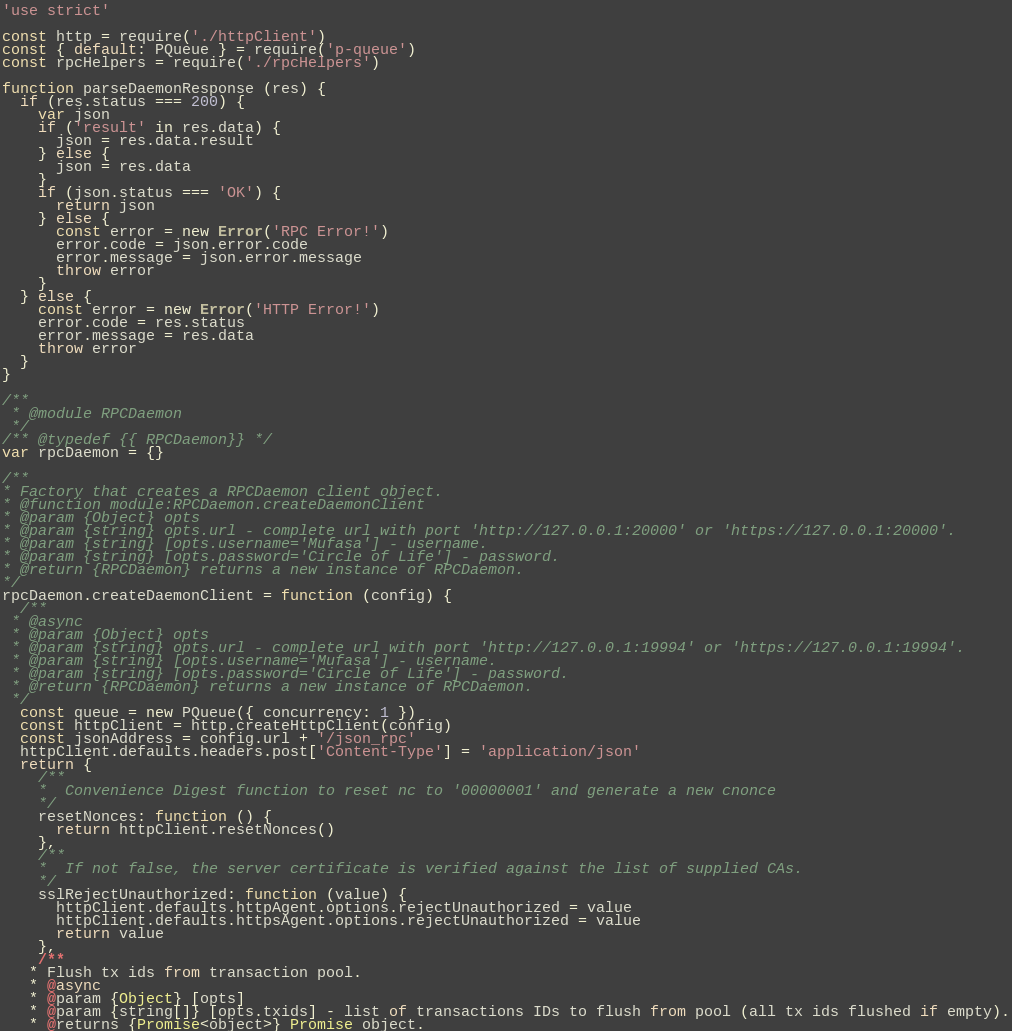<code> <loc_0><loc_0><loc_500><loc_500><_JavaScript_>'use strict'

const http = require('./httpClient')
const { default: PQueue } = require('p-queue')
const rpcHelpers = require('./rpcHelpers')

function parseDaemonResponse (res) {
  if (res.status === 200) {
    var json
    if ('result' in res.data) {
      json = res.data.result
    } else {
      json = res.data
    }
    if (json.status === 'OK') {
      return json
    } else {
      const error = new Error('RPC Error!')
      error.code = json.error.code
      error.message = json.error.message
      throw error
    }
  } else {
    const error = new Error('HTTP Error!')
    error.code = res.status
    error.message = res.data
    throw error
  }
}

/**
 * @module RPCDaemon
 */
/** @typedef {{ RPCDaemon}} */
var rpcDaemon = {}

/**
* Factory that creates a RPCDaemon client object.
* @function module:RPCDaemon.createDaemonClient
* @param {Object} opts
* @param {string} opts.url - complete url with port 'http://127.0.0.1:20000' or 'https://127.0.0.1:20000'.
* @param {string} [opts.username='Mufasa'] - username.
* @param {string} [opts.password='Circle of Life'] - password.
* @return {RPCDaemon} returns a new instance of RPCDaemon.
*/
rpcDaemon.createDaemonClient = function (config) {
  /**
 * @async
 * @param {Object} opts
 * @param {string} opts.url - complete url with port 'http://127.0.0.1:19994' or 'https://127.0.0.1:19994'.
 * @param {string} [opts.username='Mufasa'] - username.
 * @param {string} [opts.password='Circle of Life'] - password.
 * @return {RPCDaemon} returns a new instance of RPCDaemon.
 */
  const queue = new PQueue({ concurrency: 1 })
  const httpClient = http.createHttpClient(config)
  const jsonAddress = config.url + '/json_rpc'
  httpClient.defaults.headers.post['Content-Type'] = 'application/json'
  return {
    /**
    *  Convenience Digest function to reset nc to '00000001' and generate a new cnonce
    */
    resetNonces: function () {
      return httpClient.resetNonces()
    },
    /**
    *  If not false, the server certificate is verified against the list of supplied CAs.
    */
    sslRejectUnauthorized: function (value) {
      httpClient.defaults.httpAgent.options.rejectUnauthorized = value
      httpClient.defaults.httpsAgent.options.rejectUnauthorized = value
      return value
    },
    /**
   * Flush tx ids from transaction pool.
   * @async
   * @param {Object} [opts]
   * @param {string[]} [opts.txids] - list of transactions IDs to flush from pool (all tx ids flushed if empty).
   * @returns {Promise<object>} Promise object.</code> 